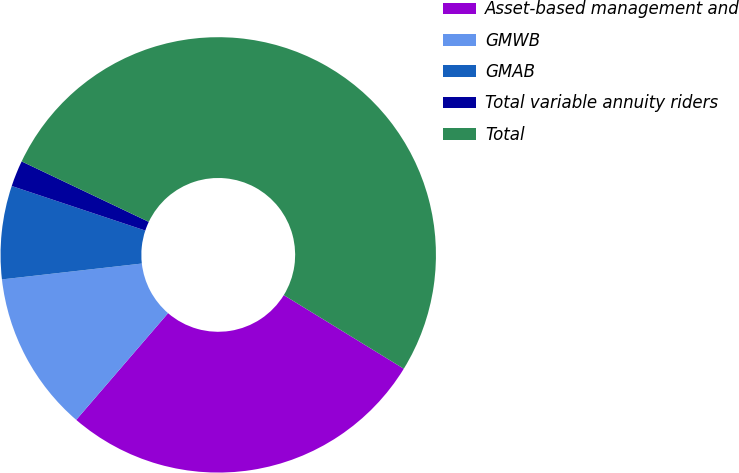Convert chart. <chart><loc_0><loc_0><loc_500><loc_500><pie_chart><fcel>Asset-based management and<fcel>GMWB<fcel>GMAB<fcel>Total variable annuity riders<fcel>Total<nl><fcel>27.55%<fcel>11.89%<fcel>6.92%<fcel>1.94%<fcel>51.69%<nl></chart> 